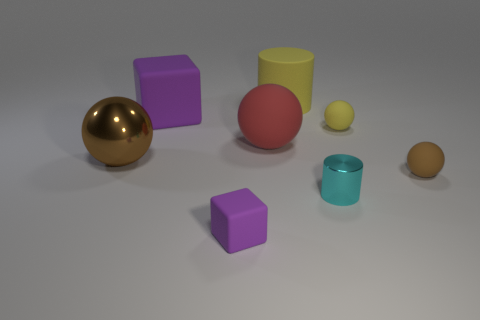Is the cyan cylinder the same size as the yellow rubber sphere?
Ensure brevity in your answer.  Yes. What number of other objects are there of the same size as the brown rubber object?
Your answer should be compact. 3. Do the big block and the small cube have the same color?
Your answer should be compact. Yes. There is a brown object that is to the left of the purple rubber block that is behind the rubber object in front of the cyan metallic object; what is its shape?
Keep it short and to the point. Sphere. What number of objects are cylinders that are in front of the large brown thing or spheres that are right of the tiny purple object?
Give a very brief answer. 4. There is a rubber object in front of the small rubber object to the right of the small yellow rubber ball; what is its size?
Provide a short and direct response. Small. There is a metal object on the left side of the large matte cylinder; is its color the same as the large matte ball?
Ensure brevity in your answer.  No. Is there a big red thing of the same shape as the tiny yellow object?
Provide a succinct answer. Yes. There is a ball that is the same size as the red thing; what color is it?
Provide a succinct answer. Brown. What is the size of the purple rubber object that is in front of the tiny yellow rubber object?
Ensure brevity in your answer.  Small. 